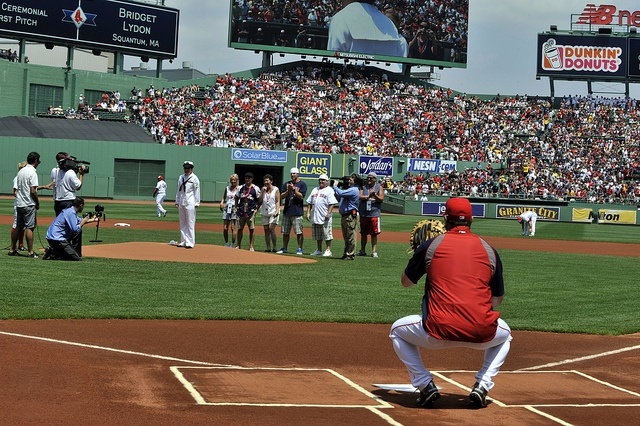Describe the objects in this image and their specific colors. I can see people in black, brown, and gray tones, people in black, gray, and lightblue tones, people in black, lightgray, gray, and darkgray tones, people in black, gray, brown, and darkgreen tones, and people in black, gray, darkgreen, and navy tones in this image. 